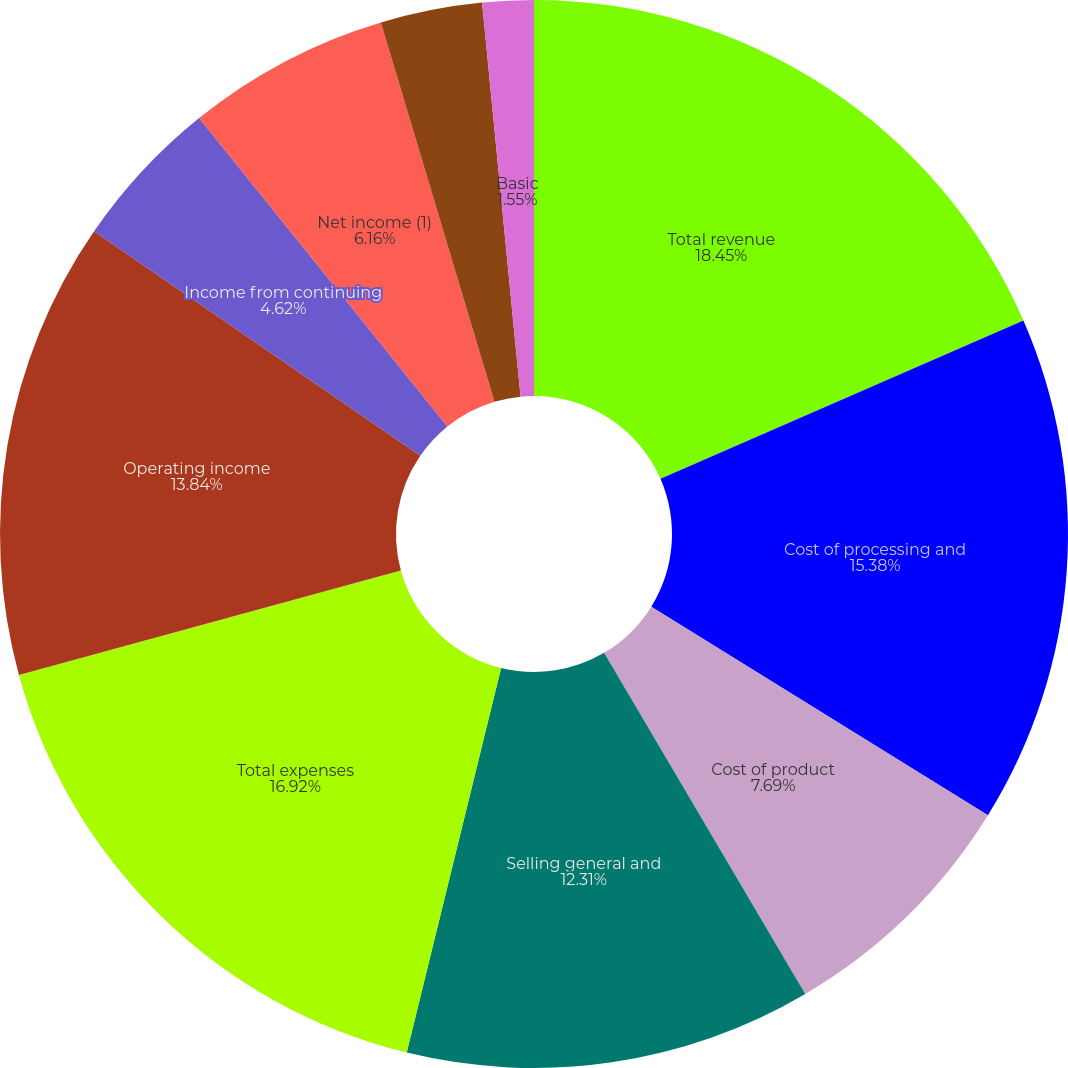Convert chart. <chart><loc_0><loc_0><loc_500><loc_500><pie_chart><fcel>Total revenue<fcel>Cost of processing and<fcel>Cost of product<fcel>Selling general and<fcel>Total expenses<fcel>Operating income<fcel>Income from continuing<fcel>Net income (1)<fcel>Comprehensive income<fcel>Basic<nl><fcel>18.45%<fcel>15.38%<fcel>7.69%<fcel>12.31%<fcel>16.92%<fcel>13.84%<fcel>4.62%<fcel>6.16%<fcel>3.08%<fcel>1.55%<nl></chart> 